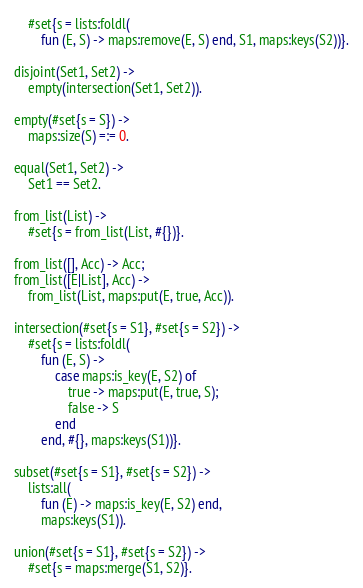Convert code to text. <code><loc_0><loc_0><loc_500><loc_500><_Erlang_>	#set{s = lists:foldl(
		fun (E, S) -> maps:remove(E, S) end, S1, maps:keys(S2))}.

disjoint(Set1, Set2) ->
	empty(intersection(Set1, Set2)).

empty(#set{s = S}) ->
	maps:size(S) =:= 0.

equal(Set1, Set2) ->
	Set1 == Set2.

from_list(List) ->
	#set{s = from_list(List, #{})}.

from_list([], Acc) -> Acc;
from_list([E|List], Acc) ->
	from_list(List, maps:put(E, true, Acc)).

intersection(#set{s = S1}, #set{s = S2}) ->
	#set{s = lists:foldl(
		fun (E, S) ->
			case maps:is_key(E, S2) of
				true -> maps:put(E, true, S);
				false -> S
			end
		end, #{}, maps:keys(S1))}.

subset(#set{s = S1}, #set{s = S2}) ->
	lists:all(
		fun (E) -> maps:is_key(E, S2) end,
		maps:keys(S1)).

union(#set{s = S1}, #set{s = S2}) ->
	#set{s = maps:merge(S1, S2)}.
</code> 